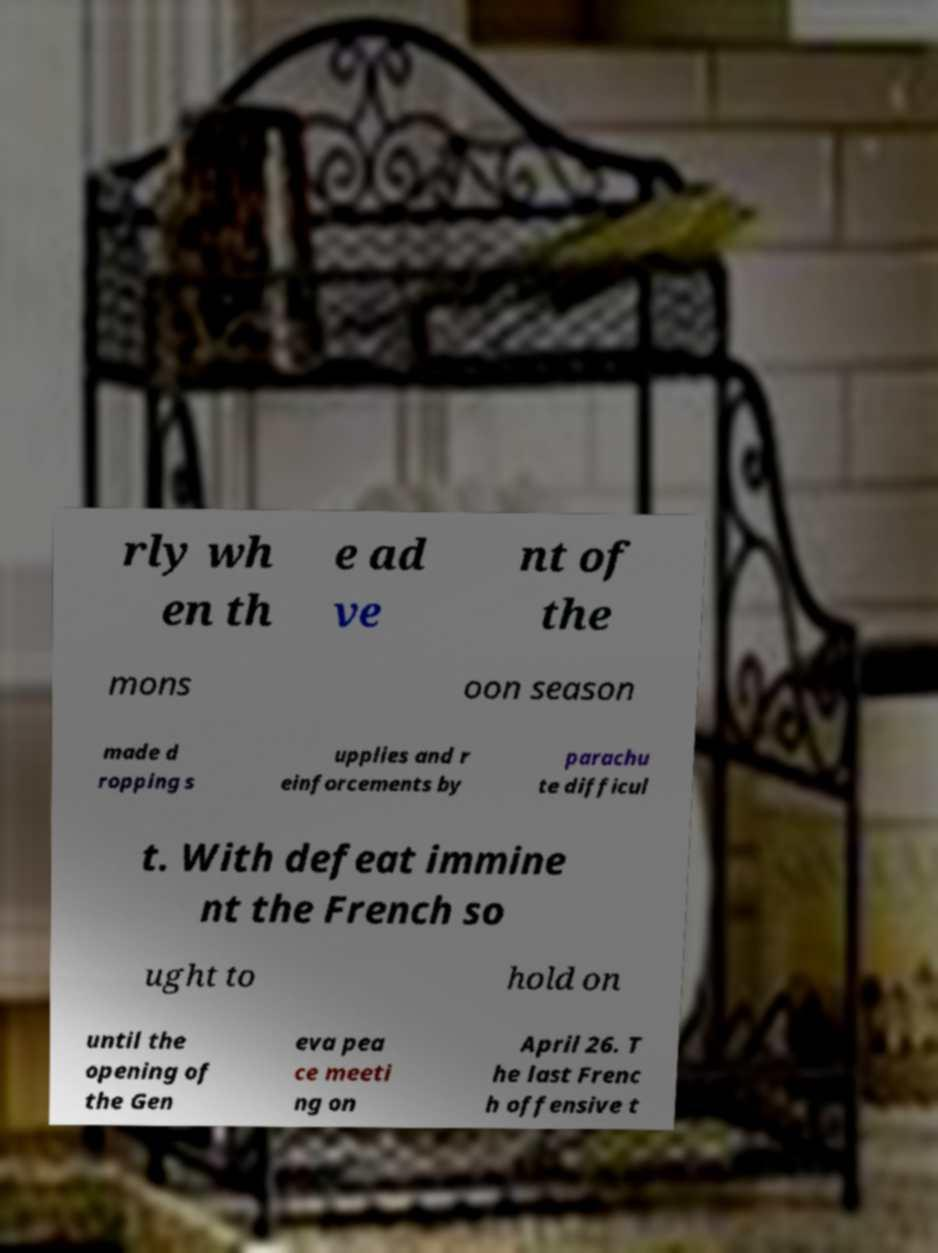Please identify and transcribe the text found in this image. rly wh en th e ad ve nt of the mons oon season made d ropping s upplies and r einforcements by parachu te difficul t. With defeat immine nt the French so ught to hold on until the opening of the Gen eva pea ce meeti ng on April 26. T he last Frenc h offensive t 